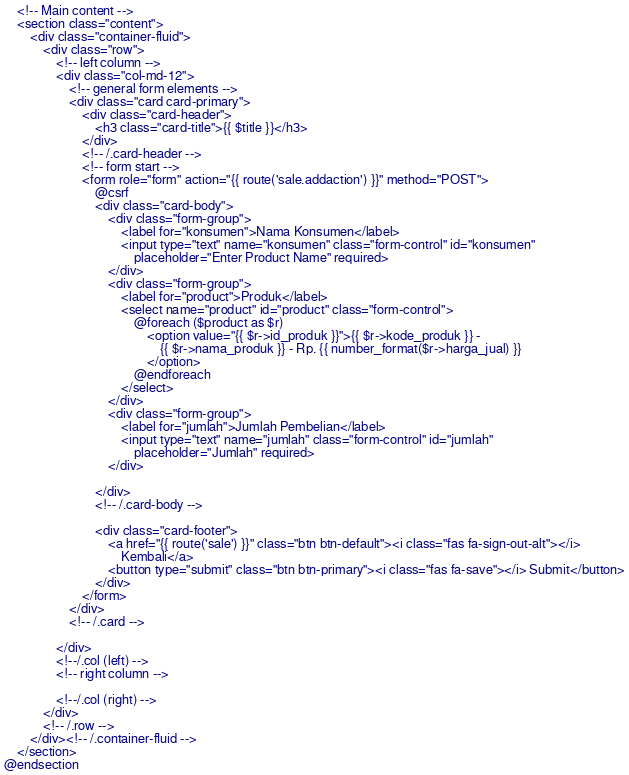Convert code to text. <code><loc_0><loc_0><loc_500><loc_500><_PHP_>    <!-- Main content -->
    <section class="content">
        <div class="container-fluid">
            <div class="row">
                <!-- left column -->
                <div class="col-md-12">
                    <!-- general form elements -->
                    <div class="card card-primary">
                        <div class="card-header">
                            <h3 class="card-title">{{ $title }}</h3>
                        </div>
                        <!-- /.card-header -->
                        <!-- form start -->
                        <form role="form" action="{{ route('sale.addaction') }}" method="POST">
                            @csrf
                            <div class="card-body">
                                <div class="form-group">
                                    <label for="konsumen">Nama Konsumen</label>
                                    <input type="text" name="konsumen" class="form-control" id="konsumen"
                                        placeholder="Enter Product Name" required>
                                </div>
                                <div class="form-group">
                                    <label for="product">Produk</label>
                                    <select name="product" id="product" class="form-control">
                                        @foreach ($product as $r)
                                            <option value="{{ $r->id_produk }}">{{ $r->kode_produk }} -
                                                {{ $r->nama_produk }} - Rp. {{ number_format($r->harga_jual) }}
                                            </option>
                                        @endforeach
                                    </select>
                                </div>
                                <div class="form-group">
                                    <label for="jumlah">Jumlah Pembelian</label>
                                    <input type="text" name="jumlah" class="form-control" id="jumlah"
                                        placeholder="Jumlah" required>
                                </div>

                            </div>
                            <!-- /.card-body -->

                            <div class="card-footer">
                                <a href="{{ route('sale') }}" class="btn btn-default"><i class="fas fa-sign-out-alt"></i>
                                    Kembali</a>
                                <button type="submit" class="btn btn-primary"><i class="fas fa-save"></i> Submit</button>
                            </div>
                        </form>
                    </div>
                    <!-- /.card -->

                </div>
                <!--/.col (left) -->
                <!-- right column -->

                <!--/.col (right) -->
            </div>
            <!-- /.row -->
        </div><!-- /.container-fluid -->
    </section>
@endsection
</code> 